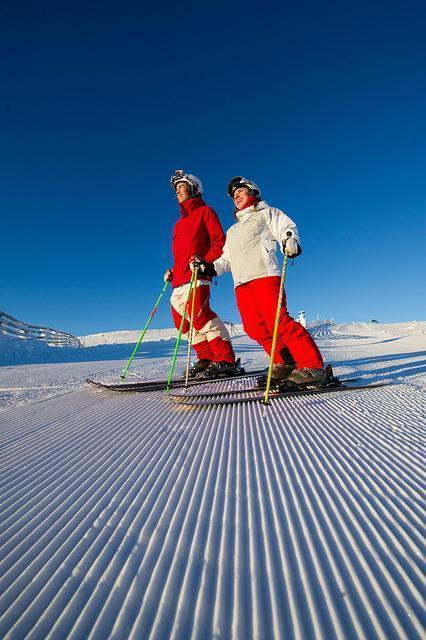How many people are shown?
Give a very brief answer. 2. How many people are there?
Give a very brief answer. 2. How many people are in the picture?
Give a very brief answer. 2. How many bikes are there?
Give a very brief answer. 0. 